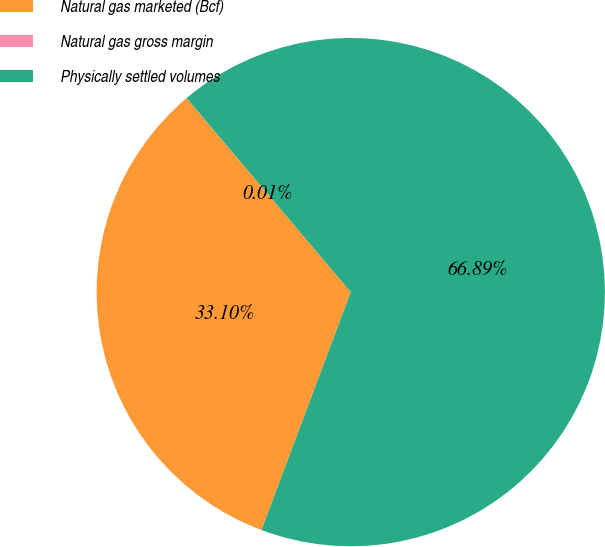Convert chart to OTSL. <chart><loc_0><loc_0><loc_500><loc_500><pie_chart><fcel>Natural gas marketed (Bcf)<fcel>Natural gas gross margin<fcel>Physically settled volumes<nl><fcel>33.1%<fcel>0.01%<fcel>66.9%<nl></chart> 